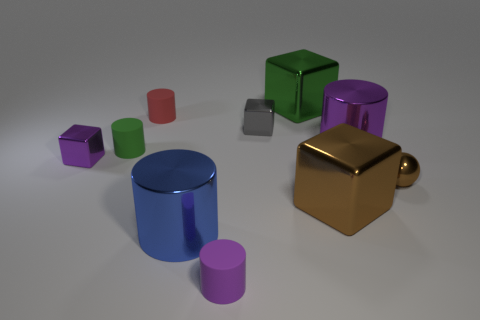How many brown objects have the same material as the big blue cylinder? Upon careful examination of the image, I can determine that there is only one brown object which appears to have a reflective metal-like material similar to that of the big blue cylinder. Therefore, the answer to the question would be one. 